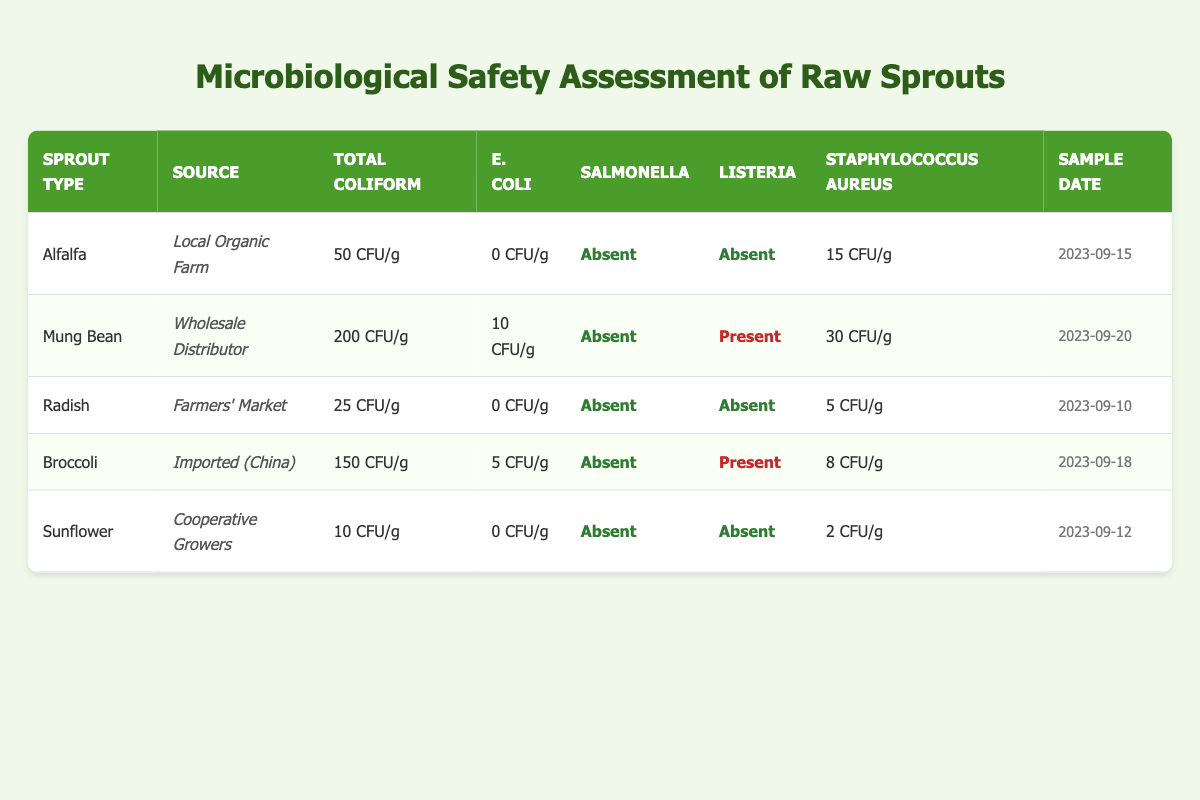What is the total coliform count for Mung Bean from the Wholesale Distributor? The table shows that the total coliform count for Mung Bean sourced from the Wholesale Distributor is "200 CFU/g." I found this value directly in the corresponding row for Mung Bean.
Answer: 200 CFU/g Which sprout type has the highest E. coli count? Scanning through the table, I notice that Mung Bean has an E. coli count of "10 CFU/g," which is higher than Broccoli's "5 CFU/g." Other sprout types like Alfalfa, Radish, and Sunflower have "0 CFU/g," so Mung Bean is the one with the highest count.
Answer: Mung Bean Are there any sprouts present with Listeria? Looking at the Listeria column, I see that both Mung Bean and Broccoli have "Present" listed, while the rest show "Absent". Therefore, there are sprouts that have Listeria present.
Answer: Yes What is the average count of Staphylococcus aureus among the sprouts tested? First, I will sum up the Staphylococcus aureus counts: 15 + 30 + 5 + 8 + 2 = 60 CFU/g. There are 5 samples in total, so the average is 60 CFU/g divided by 5, which equals 12 CFU/g.
Answer: 12 CFU/g Which sprout has the lowest total coliform count? Looking up the total coliform counts in the table, I find that Sunflower has the lowest at "10 CFU/g," compared to Alfalfa's "50 CFU/g," Mung Bean’s "200 CFU/g," Broccoli's "150 CFU/g," and Radish’s "25 CFU/g."
Answer: Sunflower 